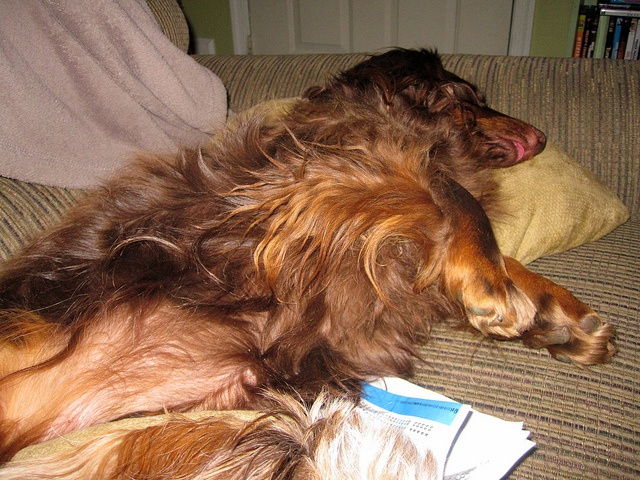Describe the objects in this image and their specific colors. I can see dog in gray, maroon, brown, and tan tones, couch in gray and tan tones, book in gray, darkgreen, and black tones, and book in gray and black tones in this image. 